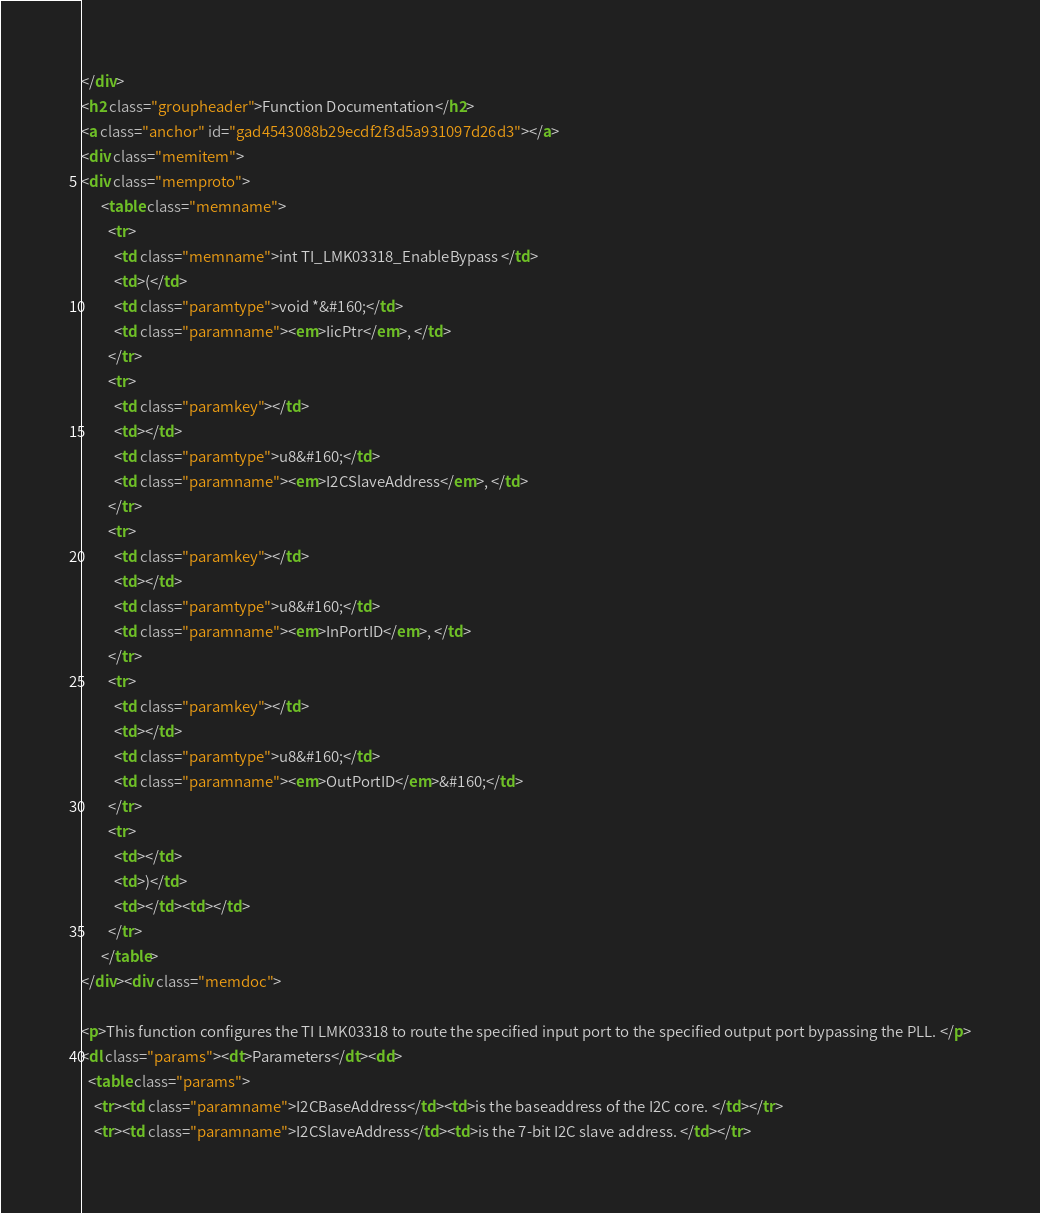Convert code to text. <code><loc_0><loc_0><loc_500><loc_500><_HTML_></div>
<h2 class="groupheader">Function Documentation</h2>
<a class="anchor" id="gad4543088b29ecdf2f3d5a931097d26d3"></a>
<div class="memitem">
<div class="memproto">
      <table class="memname">
        <tr>
          <td class="memname">int TI_LMK03318_EnableBypass </td>
          <td>(</td>
          <td class="paramtype">void *&#160;</td>
          <td class="paramname"><em>IicPtr</em>, </td>
        </tr>
        <tr>
          <td class="paramkey"></td>
          <td></td>
          <td class="paramtype">u8&#160;</td>
          <td class="paramname"><em>I2CSlaveAddress</em>, </td>
        </tr>
        <tr>
          <td class="paramkey"></td>
          <td></td>
          <td class="paramtype">u8&#160;</td>
          <td class="paramname"><em>InPortID</em>, </td>
        </tr>
        <tr>
          <td class="paramkey"></td>
          <td></td>
          <td class="paramtype">u8&#160;</td>
          <td class="paramname"><em>OutPortID</em>&#160;</td>
        </tr>
        <tr>
          <td></td>
          <td>)</td>
          <td></td><td></td>
        </tr>
      </table>
</div><div class="memdoc">

<p>This function configures the TI LMK03318 to route the specified input port to the specified output port bypassing the PLL. </p>
<dl class="params"><dt>Parameters</dt><dd>
  <table class="params">
    <tr><td class="paramname">I2CBaseAddress</td><td>is the baseaddress of the I2C core. </td></tr>
    <tr><td class="paramname">I2CSlaveAddress</td><td>is the 7-bit I2C slave address. </td></tr></code> 